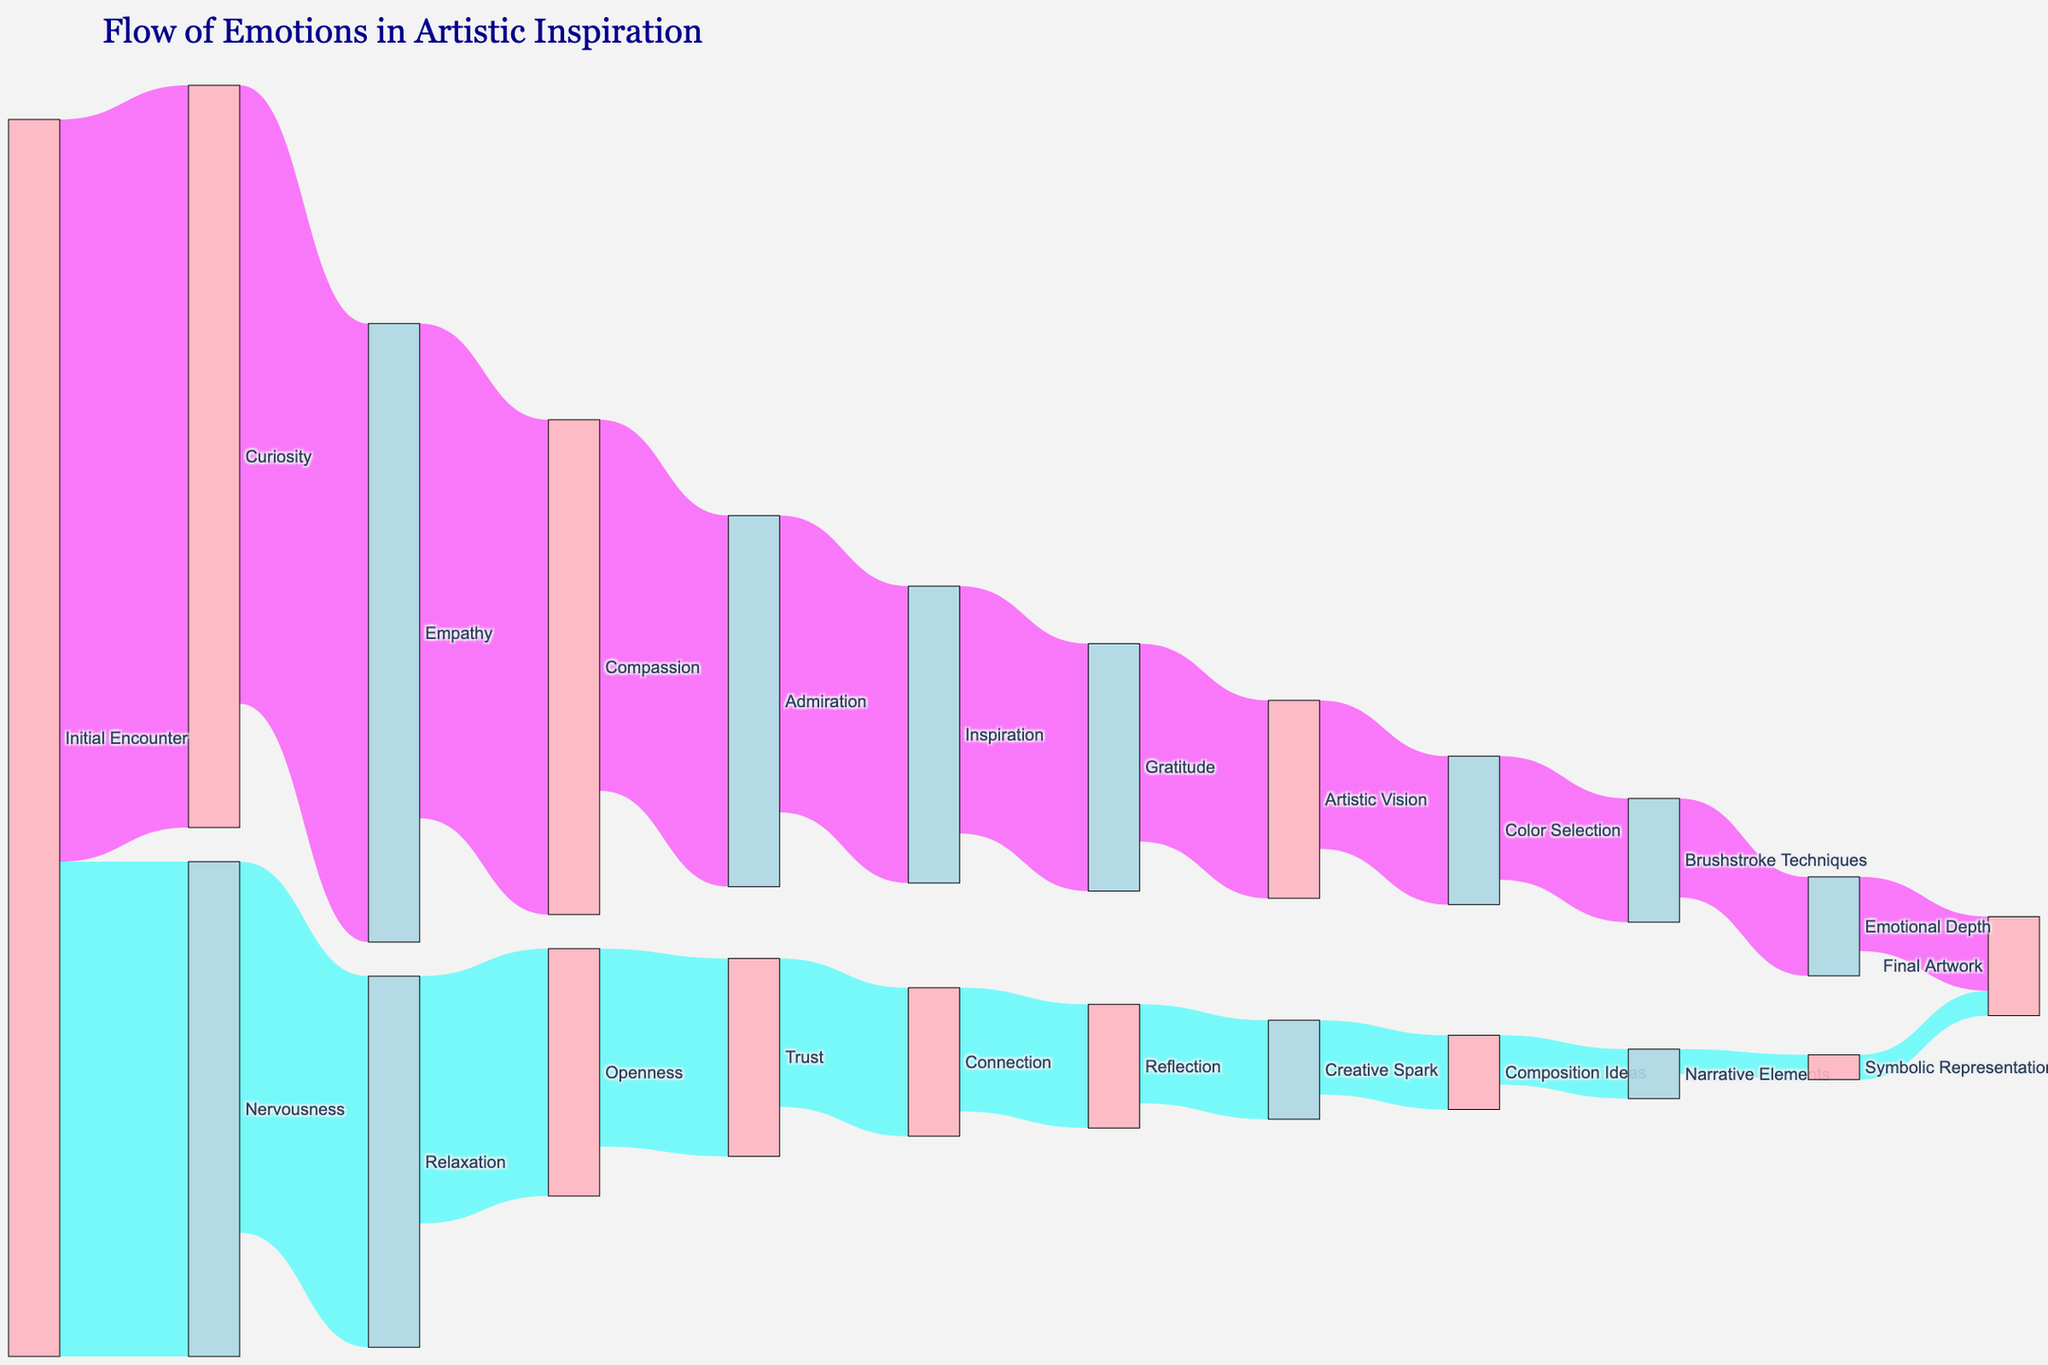What is the title of the Sankey diagram? The title appears at the top of the diagram, indicating what the chart represents.
Answer: Flow of Emotions in Artistic Inspiration What is the initial emotion experienced during the encounter? The initial emotions are shown at the beginning of the Sankey diagram, with the labels leading from 'Initial Encounter'.
Answer: Curiosity, Nervousness Which emotion has the highest flow starting from 'Initial Encounter'? By looking at the flow values starting from 'Initial Encounter', the highest value indicates the most significant emotional flow.
Answer: Curiosity How many emotions are involved in the diagram? Count the unique labels in the Sankey diagram representing different emotions.
Answer: 22 Which path leads from 'Admiration' to 'Final Artwork'? Trace the sequence of emotions starting from 'Admiration' leading to 'Final Artwork' through intermediary steps.
Answer: Admiration -> Inspiration -> Gratitude -> Artistic Vision -> Color Selection -> Brushstroke Techniques -> Emotional Depth -> Final Artwork Which emotion directly follows 'Trust'? Find the node directly connected from 'Trust' to identify the subsequent emotion.
Answer: Connection What is the combined value of flows from 'Empathy'? Sum the flow values leading from the 'Empathy' node to its immediate targets.
Answer: 20 How many emotions lead directly to 'Final Artwork'? Count the direct connections that flow into 'Final Artwork'.
Answer: 2 Which emotion has the highest number of direct connections to different emotions? Identify the node with the highest number of outflow paths to other nodes.
Answer: Initial Encounter Which emotion follows 'Creative Spark' before reaching 'Final Artwork'? Trace the path starting from 'Creative Spark' to find the intermediary step before 'Final Artwork'.
Answer: Composition Ideas 